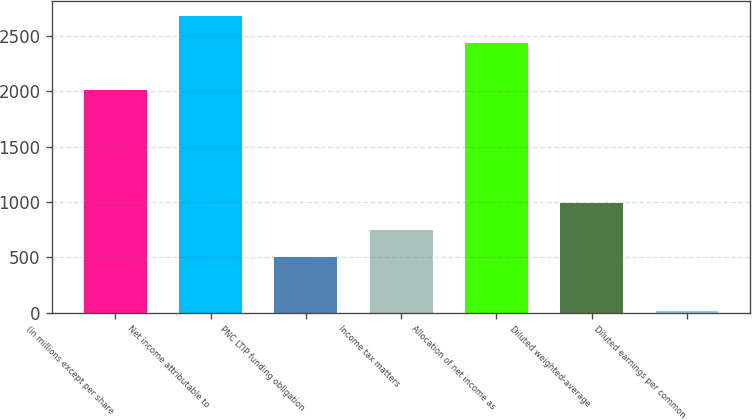Convert chart. <chart><loc_0><loc_0><loc_500><loc_500><bar_chart><fcel>(in millions except per share<fcel>Net income attributable to<fcel>PNC LTIP funding obligation<fcel>Income tax matters<fcel>Allocation of net income as<fcel>Diluted weighted-average<fcel>Diluted earnings per common<nl><fcel>2012<fcel>2679.43<fcel>502.54<fcel>746.97<fcel>2435<fcel>991.4<fcel>13.68<nl></chart> 